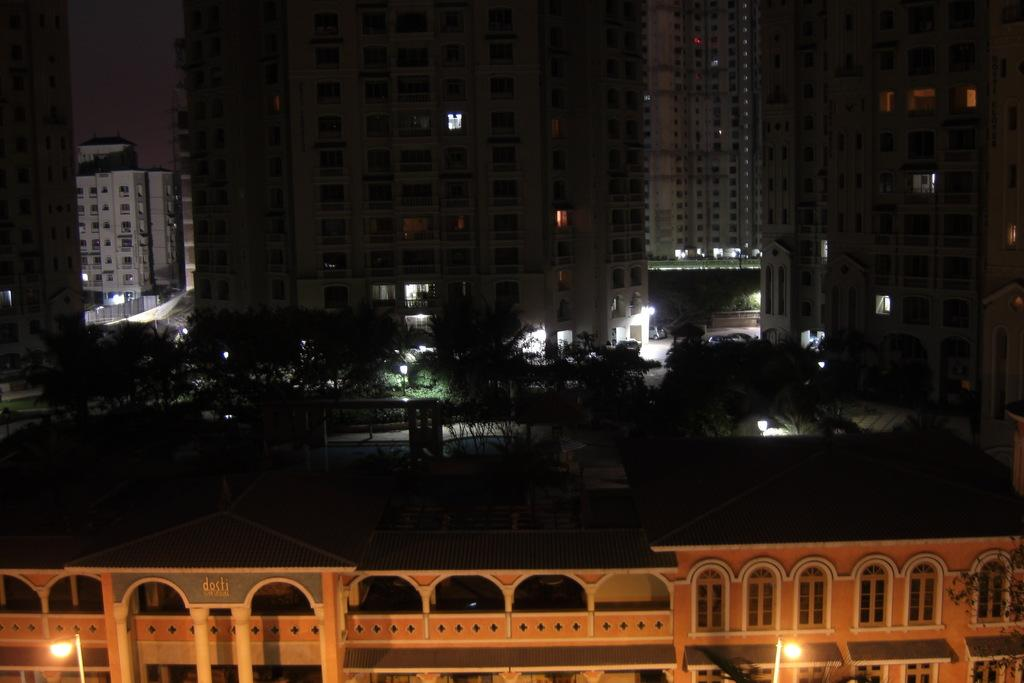What type of structures can be seen in the image? There are buildings in the image. What type of vegetation is present in the image? There are trees in the image. Can you describe the setting of the image? The image features a combination of man-made structures and natural elements, such as buildings and trees. Where is the scarecrow located in the image? There is no scarecrow present in the image. What type of animal can be seen interacting with the trees in the image? There are no animals depicted in the image; it only features buildings and trees. 